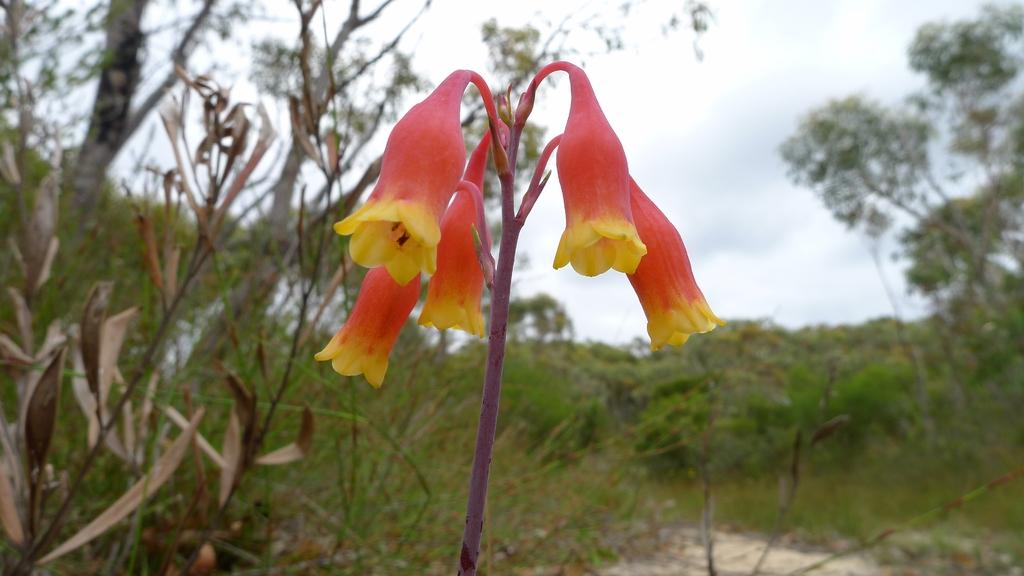What type of vegetation can be seen in the image? There are flower plants, grass, and trees in the image. What natural environment is visible in the image? The natural environment includes grass, trees, and the sky, which is visible in the background of the image. How many basketballs can be seen in the image? There are no basketballs present in the image. What type of wave is visible in the image? There is no wave visible in the image; it features flower plants, grass, trees, and the sky. 